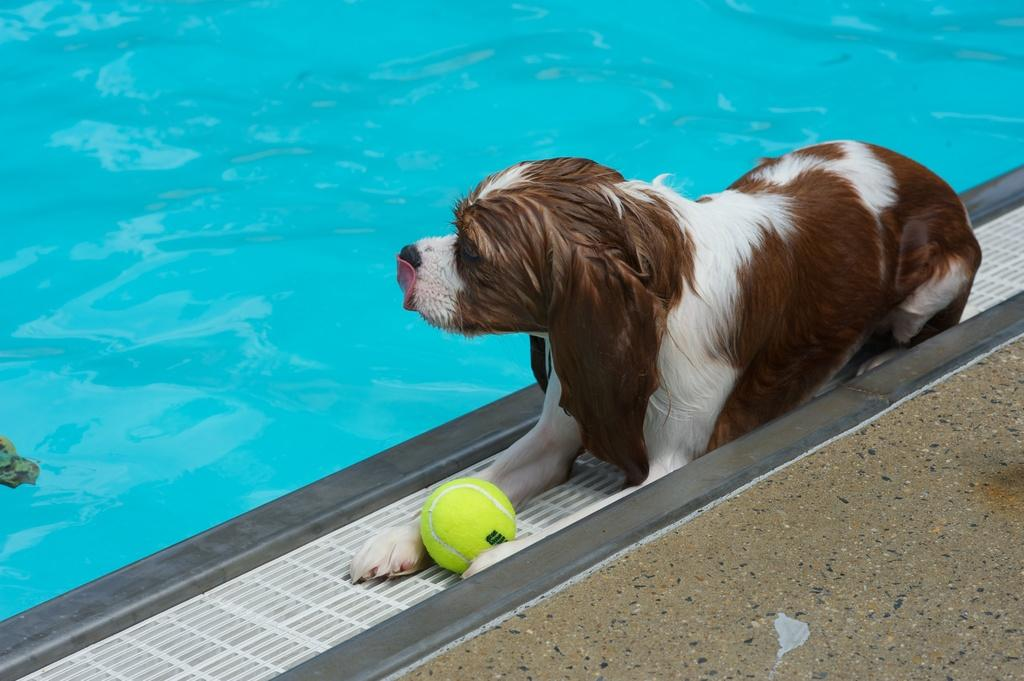What is located in the foreground of the image? There is a dog and a ball in the foreground of the image. What is the surface that the dog and ball are on? The floor is visible in the foreground of the image. What can be seen at the top of the image? There is swimming pool water at the top of the image. Where is the pocket located in the image? There is no pocket present in the image. What type of fuel is being used by the dog in the image? Dogs do not use fuel, and there is no indication of any fuel in the image. 